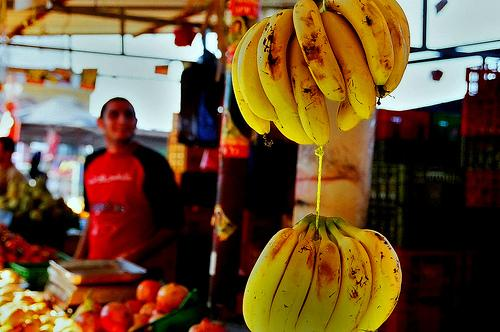What can hanging the bananas avoid? Please explain your reasoning. black spots. Hanging up bananas can keep them fresh longer and avoid them going bad. 